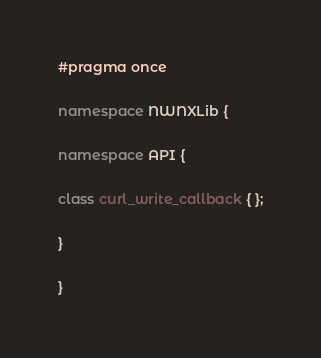<code> <loc_0><loc_0><loc_500><loc_500><_C++_>#pragma once

namespace NWNXLib {

namespace API {

class curl_write_callback { };

}

}
</code> 